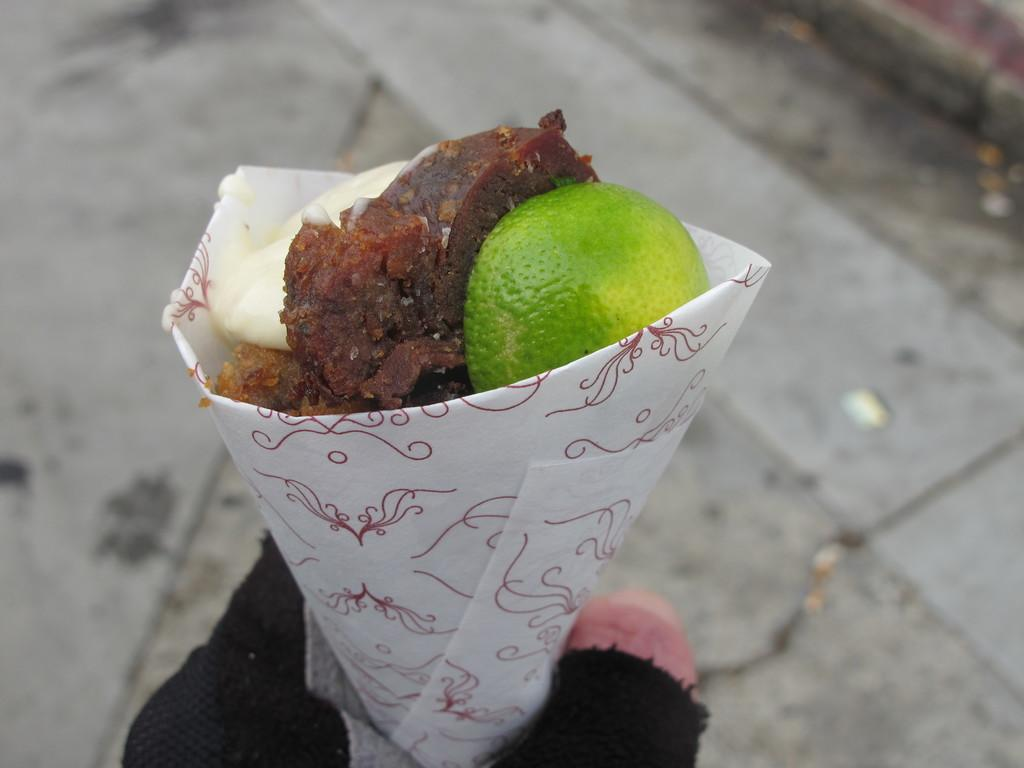What is the person's hand holding in the image? The person's hand is holding an object that contains a food item. Can you describe the food item in the object? Unfortunately, the specific food item cannot be determined from the provided facts. What can be seen below the hand in the image? The ground is visible in the image. What type of stamp can be seen on the person's hand in the image? There is no stamp present on the person's hand in the image. Can you describe the wren that is perched on the food item in the image? There is no wren present in the image; it only features a person's hand holding an object containing a food item. 